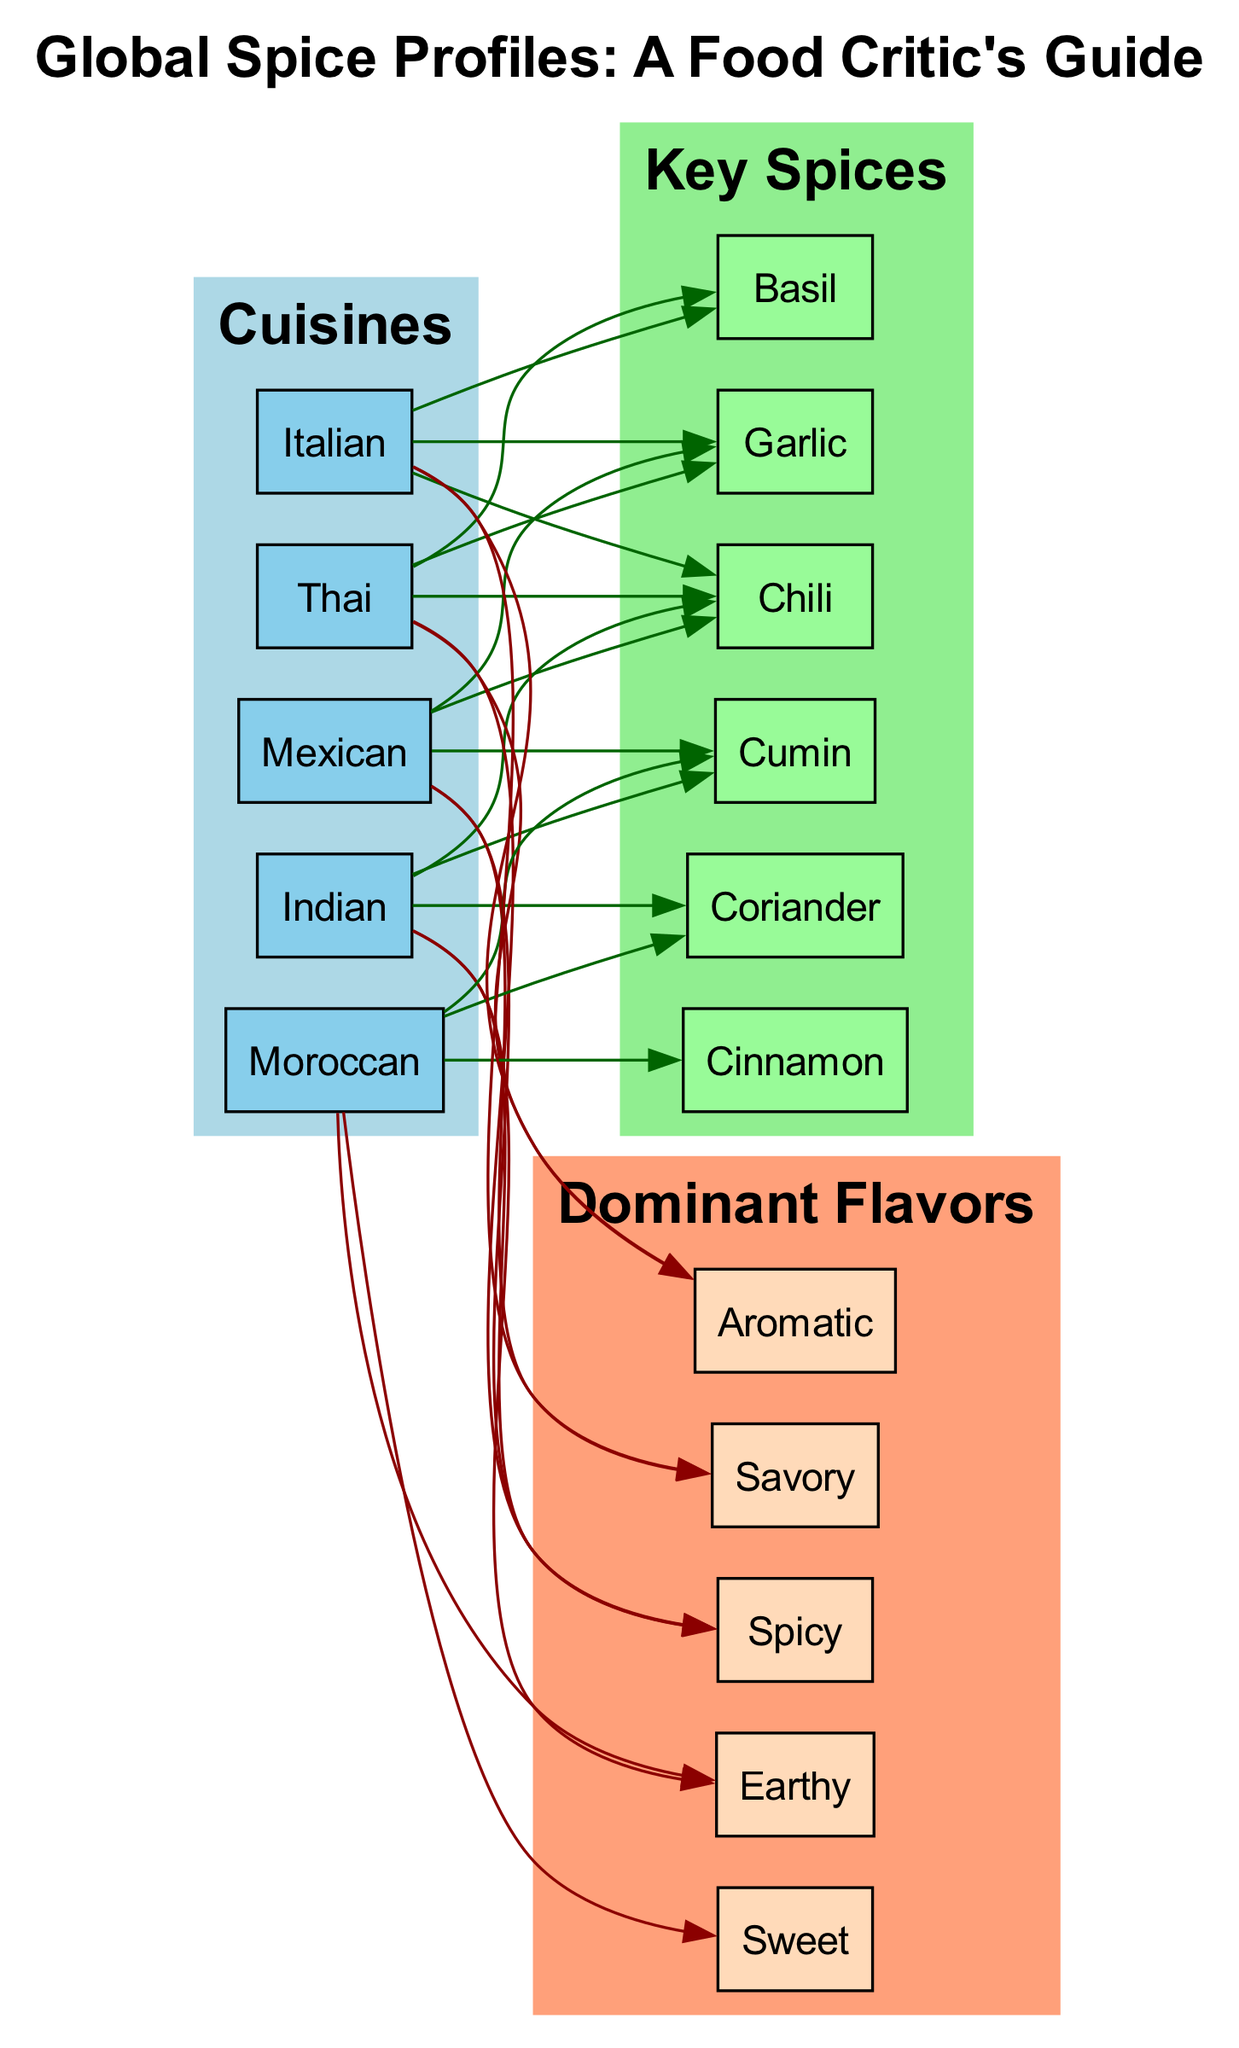What are the three key spices in Indian cuisine? The diagram specifies that the key spices connected to 'Indian' are 'Cumin', 'Coriander', and 'Chili'. By examining the connections in the 'cluster_cuisines', we find these three spices listed.
Answer: Cumin, Coriander, Chili How many cuisines are represented in the diagram? By counting the nodes in the 'cluster_cuisines', we see five cuisines listed: Indian, Mexican, Thai, Moroccan, and Italian. A simple count of these nodes indicates the total.
Answer: 5 Which cuisine uses 'Cinnamon' as a key spice? Looking at the connections for 'Cinnamon', the diagram shows it is connected to 'Moroccan'. Therefore, 'Cinnamon' is specifically associated with this cuisine.
Answer: Moroccan What are the dominant flavors of Thai cuisine? The diagram connects 'Thai' to the flavors 'Spicy' and 'Aromatic'. By directly referencing the connections for 'Thai', we identify these two flavor descriptions.
Answer: Spicy, Aromatic Which cuisine does not have 'Cumin' listed as a key spice? Analyzing the connections, we find that 'Cumin' is associated with Indian, Mexican, and Moroccan cuisines. The only cuisine without 'Cumin' is 'Thai', as its key spices are 'Chili', 'Garlic', and 'Basil'.
Answer: Thai How many dominant flavors are associated with Italian cuisine? In the diagram, 'Italian' connects to the flavors 'Savory' and 'Aromatic'. By counting these connections, we determine that there are two dominant flavors for this cuisine.
Answer: 2 Which key spice is common in both Indian and Mexican cuisines? The diagram links 'Cumin' to both 'Indian' and 'Mexican'. By looking at the key spices for both cuisines, we see that 'Cumin' is the shared spice.
Answer: Cumin What is the color of the node labeled "Cuisines"? The 'cluster_cuisines' subgraph is colored light blue, as shown in the diagram attributes. Thus, the node labeled "Cuisines" will be filled with this color.
Answer: Light blue Which cuisine has the sweetest flavor profile? The connection shows that 'Moroccan' is associated with the flavor 'Sweet'. Upon reviewing the dominant flavors for each cuisine, 'Moroccan' stands out for having this flavor.
Answer: Moroccan 